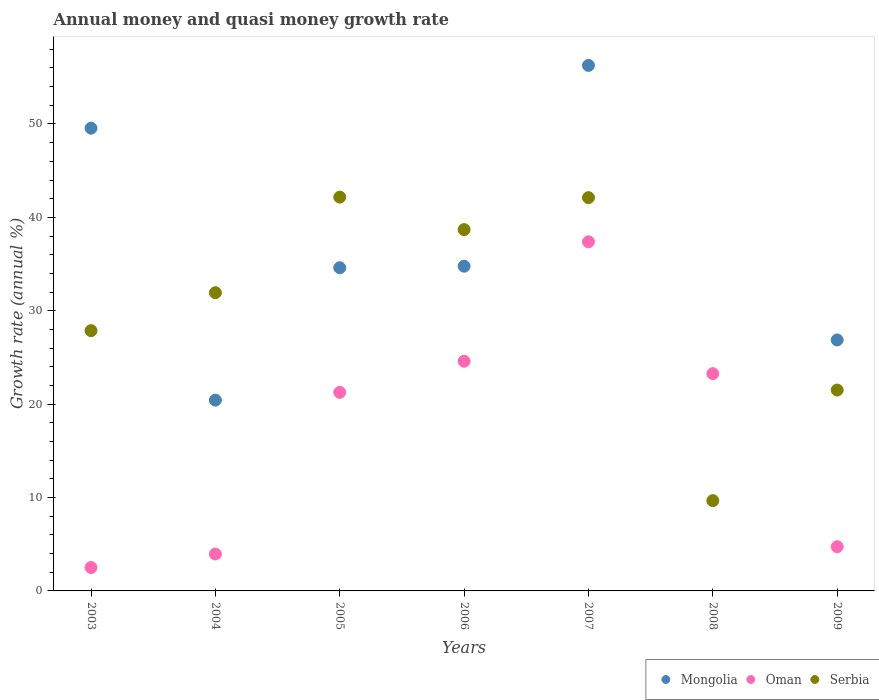What is the growth rate in Oman in 2009?
Provide a short and direct response. 4.73. Across all years, what is the maximum growth rate in Mongolia?
Offer a terse response. 56.27. Across all years, what is the minimum growth rate in Mongolia?
Your response must be concise. 0. What is the total growth rate in Mongolia in the graph?
Your response must be concise. 222.5. What is the difference between the growth rate in Oman in 2003 and that in 2009?
Your answer should be very brief. -2.22. What is the difference between the growth rate in Mongolia in 2004 and the growth rate in Oman in 2005?
Your answer should be very brief. -0.83. What is the average growth rate in Mongolia per year?
Make the answer very short. 31.79. In the year 2007, what is the difference between the growth rate in Mongolia and growth rate in Oman?
Give a very brief answer. 18.89. What is the ratio of the growth rate in Serbia in 2003 to that in 2009?
Provide a succinct answer. 1.3. What is the difference between the highest and the second highest growth rate in Serbia?
Offer a very short reply. 0.06. What is the difference between the highest and the lowest growth rate in Serbia?
Ensure brevity in your answer.  32.5. Does the growth rate in Serbia monotonically increase over the years?
Offer a terse response. No. Is the growth rate in Oman strictly less than the growth rate in Serbia over the years?
Your answer should be very brief. No. How many years are there in the graph?
Your answer should be compact. 7. Are the values on the major ticks of Y-axis written in scientific E-notation?
Your answer should be compact. No. Does the graph contain grids?
Make the answer very short. No. Where does the legend appear in the graph?
Your answer should be compact. Bottom right. How many legend labels are there?
Give a very brief answer. 3. What is the title of the graph?
Ensure brevity in your answer.  Annual money and quasi money growth rate. Does "Algeria" appear as one of the legend labels in the graph?
Your response must be concise. No. What is the label or title of the Y-axis?
Keep it short and to the point. Growth rate (annual %). What is the Growth rate (annual %) of Mongolia in 2003?
Your answer should be very brief. 49.55. What is the Growth rate (annual %) in Oman in 2003?
Keep it short and to the point. 2.51. What is the Growth rate (annual %) of Serbia in 2003?
Offer a very short reply. 27.87. What is the Growth rate (annual %) of Mongolia in 2004?
Make the answer very short. 20.43. What is the Growth rate (annual %) in Oman in 2004?
Offer a very short reply. 3.95. What is the Growth rate (annual %) in Serbia in 2004?
Your response must be concise. 31.93. What is the Growth rate (annual %) of Mongolia in 2005?
Give a very brief answer. 34.61. What is the Growth rate (annual %) in Oman in 2005?
Your answer should be very brief. 21.26. What is the Growth rate (annual %) in Serbia in 2005?
Offer a very short reply. 42.17. What is the Growth rate (annual %) in Mongolia in 2006?
Offer a terse response. 34.77. What is the Growth rate (annual %) in Oman in 2006?
Keep it short and to the point. 24.6. What is the Growth rate (annual %) of Serbia in 2006?
Keep it short and to the point. 38.69. What is the Growth rate (annual %) in Mongolia in 2007?
Your response must be concise. 56.27. What is the Growth rate (annual %) of Oman in 2007?
Offer a very short reply. 37.39. What is the Growth rate (annual %) in Serbia in 2007?
Offer a very short reply. 42.11. What is the Growth rate (annual %) of Oman in 2008?
Offer a very short reply. 23.27. What is the Growth rate (annual %) in Serbia in 2008?
Give a very brief answer. 9.67. What is the Growth rate (annual %) of Mongolia in 2009?
Your answer should be compact. 26.87. What is the Growth rate (annual %) of Oman in 2009?
Provide a short and direct response. 4.73. What is the Growth rate (annual %) in Serbia in 2009?
Keep it short and to the point. 21.51. Across all years, what is the maximum Growth rate (annual %) of Mongolia?
Provide a short and direct response. 56.27. Across all years, what is the maximum Growth rate (annual %) of Oman?
Your answer should be compact. 37.39. Across all years, what is the maximum Growth rate (annual %) of Serbia?
Offer a terse response. 42.17. Across all years, what is the minimum Growth rate (annual %) in Mongolia?
Offer a very short reply. 0. Across all years, what is the minimum Growth rate (annual %) of Oman?
Your answer should be compact. 2.51. Across all years, what is the minimum Growth rate (annual %) in Serbia?
Provide a succinct answer. 9.67. What is the total Growth rate (annual %) in Mongolia in the graph?
Keep it short and to the point. 222.5. What is the total Growth rate (annual %) in Oman in the graph?
Make the answer very short. 117.71. What is the total Growth rate (annual %) of Serbia in the graph?
Give a very brief answer. 213.95. What is the difference between the Growth rate (annual %) in Mongolia in 2003 and that in 2004?
Your answer should be very brief. 29.12. What is the difference between the Growth rate (annual %) of Oman in 2003 and that in 2004?
Make the answer very short. -1.44. What is the difference between the Growth rate (annual %) in Serbia in 2003 and that in 2004?
Provide a succinct answer. -4.06. What is the difference between the Growth rate (annual %) of Mongolia in 2003 and that in 2005?
Offer a very short reply. 14.94. What is the difference between the Growth rate (annual %) of Oman in 2003 and that in 2005?
Offer a terse response. -18.75. What is the difference between the Growth rate (annual %) of Serbia in 2003 and that in 2005?
Keep it short and to the point. -14.3. What is the difference between the Growth rate (annual %) of Mongolia in 2003 and that in 2006?
Provide a short and direct response. 14.78. What is the difference between the Growth rate (annual %) in Oman in 2003 and that in 2006?
Offer a terse response. -22.08. What is the difference between the Growth rate (annual %) of Serbia in 2003 and that in 2006?
Provide a short and direct response. -10.82. What is the difference between the Growth rate (annual %) in Mongolia in 2003 and that in 2007?
Give a very brief answer. -6.72. What is the difference between the Growth rate (annual %) in Oman in 2003 and that in 2007?
Your answer should be very brief. -34.87. What is the difference between the Growth rate (annual %) in Serbia in 2003 and that in 2007?
Offer a very short reply. -14.24. What is the difference between the Growth rate (annual %) in Oman in 2003 and that in 2008?
Ensure brevity in your answer.  -20.76. What is the difference between the Growth rate (annual %) of Serbia in 2003 and that in 2008?
Give a very brief answer. 18.2. What is the difference between the Growth rate (annual %) of Mongolia in 2003 and that in 2009?
Your response must be concise. 22.68. What is the difference between the Growth rate (annual %) in Oman in 2003 and that in 2009?
Offer a terse response. -2.22. What is the difference between the Growth rate (annual %) in Serbia in 2003 and that in 2009?
Keep it short and to the point. 6.36. What is the difference between the Growth rate (annual %) of Mongolia in 2004 and that in 2005?
Offer a terse response. -14.18. What is the difference between the Growth rate (annual %) in Oman in 2004 and that in 2005?
Offer a terse response. -17.31. What is the difference between the Growth rate (annual %) in Serbia in 2004 and that in 2005?
Offer a very short reply. -10.23. What is the difference between the Growth rate (annual %) of Mongolia in 2004 and that in 2006?
Keep it short and to the point. -14.34. What is the difference between the Growth rate (annual %) of Oman in 2004 and that in 2006?
Your answer should be very brief. -20.64. What is the difference between the Growth rate (annual %) of Serbia in 2004 and that in 2006?
Keep it short and to the point. -6.76. What is the difference between the Growth rate (annual %) of Mongolia in 2004 and that in 2007?
Provide a succinct answer. -35.84. What is the difference between the Growth rate (annual %) of Oman in 2004 and that in 2007?
Keep it short and to the point. -33.43. What is the difference between the Growth rate (annual %) in Serbia in 2004 and that in 2007?
Provide a short and direct response. -10.18. What is the difference between the Growth rate (annual %) of Oman in 2004 and that in 2008?
Offer a terse response. -19.31. What is the difference between the Growth rate (annual %) of Serbia in 2004 and that in 2008?
Provide a succinct answer. 22.27. What is the difference between the Growth rate (annual %) in Mongolia in 2004 and that in 2009?
Your response must be concise. -6.44. What is the difference between the Growth rate (annual %) of Oman in 2004 and that in 2009?
Give a very brief answer. -0.78. What is the difference between the Growth rate (annual %) of Serbia in 2004 and that in 2009?
Provide a short and direct response. 10.42. What is the difference between the Growth rate (annual %) of Mongolia in 2005 and that in 2006?
Your answer should be compact. -0.16. What is the difference between the Growth rate (annual %) in Oman in 2005 and that in 2006?
Your answer should be compact. -3.34. What is the difference between the Growth rate (annual %) in Serbia in 2005 and that in 2006?
Offer a very short reply. 3.48. What is the difference between the Growth rate (annual %) of Mongolia in 2005 and that in 2007?
Provide a succinct answer. -21.66. What is the difference between the Growth rate (annual %) in Oman in 2005 and that in 2007?
Your answer should be very brief. -16.13. What is the difference between the Growth rate (annual %) of Serbia in 2005 and that in 2007?
Your answer should be compact. 0.06. What is the difference between the Growth rate (annual %) in Oman in 2005 and that in 2008?
Provide a short and direct response. -2.01. What is the difference between the Growth rate (annual %) in Serbia in 2005 and that in 2008?
Provide a succinct answer. 32.5. What is the difference between the Growth rate (annual %) in Mongolia in 2005 and that in 2009?
Ensure brevity in your answer.  7.73. What is the difference between the Growth rate (annual %) in Oman in 2005 and that in 2009?
Offer a very short reply. 16.53. What is the difference between the Growth rate (annual %) in Serbia in 2005 and that in 2009?
Make the answer very short. 20.66. What is the difference between the Growth rate (annual %) in Mongolia in 2006 and that in 2007?
Keep it short and to the point. -21.5. What is the difference between the Growth rate (annual %) of Oman in 2006 and that in 2007?
Make the answer very short. -12.79. What is the difference between the Growth rate (annual %) in Serbia in 2006 and that in 2007?
Provide a succinct answer. -3.42. What is the difference between the Growth rate (annual %) in Oman in 2006 and that in 2008?
Your response must be concise. 1.33. What is the difference between the Growth rate (annual %) of Serbia in 2006 and that in 2008?
Your response must be concise. 29.02. What is the difference between the Growth rate (annual %) of Mongolia in 2006 and that in 2009?
Offer a terse response. 7.9. What is the difference between the Growth rate (annual %) of Oman in 2006 and that in 2009?
Offer a terse response. 19.86. What is the difference between the Growth rate (annual %) of Serbia in 2006 and that in 2009?
Your answer should be compact. 17.18. What is the difference between the Growth rate (annual %) of Oman in 2007 and that in 2008?
Provide a short and direct response. 14.12. What is the difference between the Growth rate (annual %) in Serbia in 2007 and that in 2008?
Ensure brevity in your answer.  32.44. What is the difference between the Growth rate (annual %) in Mongolia in 2007 and that in 2009?
Ensure brevity in your answer.  29.4. What is the difference between the Growth rate (annual %) of Oman in 2007 and that in 2009?
Ensure brevity in your answer.  32.65. What is the difference between the Growth rate (annual %) in Serbia in 2007 and that in 2009?
Provide a succinct answer. 20.6. What is the difference between the Growth rate (annual %) in Oman in 2008 and that in 2009?
Your answer should be compact. 18.53. What is the difference between the Growth rate (annual %) of Serbia in 2008 and that in 2009?
Your answer should be very brief. -11.84. What is the difference between the Growth rate (annual %) in Mongolia in 2003 and the Growth rate (annual %) in Oman in 2004?
Provide a succinct answer. 45.6. What is the difference between the Growth rate (annual %) in Mongolia in 2003 and the Growth rate (annual %) in Serbia in 2004?
Offer a very short reply. 17.62. What is the difference between the Growth rate (annual %) of Oman in 2003 and the Growth rate (annual %) of Serbia in 2004?
Make the answer very short. -29.42. What is the difference between the Growth rate (annual %) in Mongolia in 2003 and the Growth rate (annual %) in Oman in 2005?
Your answer should be compact. 28.29. What is the difference between the Growth rate (annual %) in Mongolia in 2003 and the Growth rate (annual %) in Serbia in 2005?
Give a very brief answer. 7.38. What is the difference between the Growth rate (annual %) of Oman in 2003 and the Growth rate (annual %) of Serbia in 2005?
Provide a short and direct response. -39.66. What is the difference between the Growth rate (annual %) in Mongolia in 2003 and the Growth rate (annual %) in Oman in 2006?
Your answer should be very brief. 24.95. What is the difference between the Growth rate (annual %) in Mongolia in 2003 and the Growth rate (annual %) in Serbia in 2006?
Make the answer very short. 10.86. What is the difference between the Growth rate (annual %) in Oman in 2003 and the Growth rate (annual %) in Serbia in 2006?
Offer a very short reply. -36.18. What is the difference between the Growth rate (annual %) of Mongolia in 2003 and the Growth rate (annual %) of Oman in 2007?
Your answer should be very brief. 12.16. What is the difference between the Growth rate (annual %) in Mongolia in 2003 and the Growth rate (annual %) in Serbia in 2007?
Ensure brevity in your answer.  7.44. What is the difference between the Growth rate (annual %) in Oman in 2003 and the Growth rate (annual %) in Serbia in 2007?
Provide a short and direct response. -39.6. What is the difference between the Growth rate (annual %) of Mongolia in 2003 and the Growth rate (annual %) of Oman in 2008?
Your answer should be compact. 26.28. What is the difference between the Growth rate (annual %) in Mongolia in 2003 and the Growth rate (annual %) in Serbia in 2008?
Make the answer very short. 39.88. What is the difference between the Growth rate (annual %) of Oman in 2003 and the Growth rate (annual %) of Serbia in 2008?
Keep it short and to the point. -7.16. What is the difference between the Growth rate (annual %) in Mongolia in 2003 and the Growth rate (annual %) in Oman in 2009?
Provide a short and direct response. 44.82. What is the difference between the Growth rate (annual %) in Mongolia in 2003 and the Growth rate (annual %) in Serbia in 2009?
Provide a short and direct response. 28.04. What is the difference between the Growth rate (annual %) of Oman in 2003 and the Growth rate (annual %) of Serbia in 2009?
Ensure brevity in your answer.  -19. What is the difference between the Growth rate (annual %) of Mongolia in 2004 and the Growth rate (annual %) of Oman in 2005?
Make the answer very short. -0.83. What is the difference between the Growth rate (annual %) in Mongolia in 2004 and the Growth rate (annual %) in Serbia in 2005?
Your answer should be very brief. -21.74. What is the difference between the Growth rate (annual %) in Oman in 2004 and the Growth rate (annual %) in Serbia in 2005?
Offer a terse response. -38.22. What is the difference between the Growth rate (annual %) of Mongolia in 2004 and the Growth rate (annual %) of Oman in 2006?
Ensure brevity in your answer.  -4.16. What is the difference between the Growth rate (annual %) of Mongolia in 2004 and the Growth rate (annual %) of Serbia in 2006?
Make the answer very short. -18.26. What is the difference between the Growth rate (annual %) of Oman in 2004 and the Growth rate (annual %) of Serbia in 2006?
Make the answer very short. -34.74. What is the difference between the Growth rate (annual %) of Mongolia in 2004 and the Growth rate (annual %) of Oman in 2007?
Your response must be concise. -16.95. What is the difference between the Growth rate (annual %) in Mongolia in 2004 and the Growth rate (annual %) in Serbia in 2007?
Offer a very short reply. -21.68. What is the difference between the Growth rate (annual %) in Oman in 2004 and the Growth rate (annual %) in Serbia in 2007?
Ensure brevity in your answer.  -38.16. What is the difference between the Growth rate (annual %) in Mongolia in 2004 and the Growth rate (annual %) in Oman in 2008?
Ensure brevity in your answer.  -2.83. What is the difference between the Growth rate (annual %) in Mongolia in 2004 and the Growth rate (annual %) in Serbia in 2008?
Give a very brief answer. 10.76. What is the difference between the Growth rate (annual %) in Oman in 2004 and the Growth rate (annual %) in Serbia in 2008?
Ensure brevity in your answer.  -5.72. What is the difference between the Growth rate (annual %) in Mongolia in 2004 and the Growth rate (annual %) in Oman in 2009?
Your response must be concise. 15.7. What is the difference between the Growth rate (annual %) of Mongolia in 2004 and the Growth rate (annual %) of Serbia in 2009?
Offer a terse response. -1.08. What is the difference between the Growth rate (annual %) of Oman in 2004 and the Growth rate (annual %) of Serbia in 2009?
Provide a succinct answer. -17.56. What is the difference between the Growth rate (annual %) of Mongolia in 2005 and the Growth rate (annual %) of Oman in 2006?
Ensure brevity in your answer.  10.01. What is the difference between the Growth rate (annual %) of Mongolia in 2005 and the Growth rate (annual %) of Serbia in 2006?
Your response must be concise. -4.08. What is the difference between the Growth rate (annual %) of Oman in 2005 and the Growth rate (annual %) of Serbia in 2006?
Give a very brief answer. -17.43. What is the difference between the Growth rate (annual %) in Mongolia in 2005 and the Growth rate (annual %) in Oman in 2007?
Your response must be concise. -2.78. What is the difference between the Growth rate (annual %) of Mongolia in 2005 and the Growth rate (annual %) of Serbia in 2007?
Your answer should be very brief. -7.5. What is the difference between the Growth rate (annual %) in Oman in 2005 and the Growth rate (annual %) in Serbia in 2007?
Offer a terse response. -20.85. What is the difference between the Growth rate (annual %) in Mongolia in 2005 and the Growth rate (annual %) in Oman in 2008?
Offer a very short reply. 11.34. What is the difference between the Growth rate (annual %) of Mongolia in 2005 and the Growth rate (annual %) of Serbia in 2008?
Your answer should be very brief. 24.94. What is the difference between the Growth rate (annual %) in Oman in 2005 and the Growth rate (annual %) in Serbia in 2008?
Your answer should be compact. 11.59. What is the difference between the Growth rate (annual %) in Mongolia in 2005 and the Growth rate (annual %) in Oman in 2009?
Offer a terse response. 29.87. What is the difference between the Growth rate (annual %) in Mongolia in 2005 and the Growth rate (annual %) in Serbia in 2009?
Keep it short and to the point. 13.1. What is the difference between the Growth rate (annual %) of Oman in 2005 and the Growth rate (annual %) of Serbia in 2009?
Your answer should be very brief. -0.25. What is the difference between the Growth rate (annual %) of Mongolia in 2006 and the Growth rate (annual %) of Oman in 2007?
Your response must be concise. -2.62. What is the difference between the Growth rate (annual %) in Mongolia in 2006 and the Growth rate (annual %) in Serbia in 2007?
Ensure brevity in your answer.  -7.34. What is the difference between the Growth rate (annual %) in Oman in 2006 and the Growth rate (annual %) in Serbia in 2007?
Offer a terse response. -17.51. What is the difference between the Growth rate (annual %) in Mongolia in 2006 and the Growth rate (annual %) in Oman in 2008?
Give a very brief answer. 11.5. What is the difference between the Growth rate (annual %) in Mongolia in 2006 and the Growth rate (annual %) in Serbia in 2008?
Your answer should be very brief. 25.1. What is the difference between the Growth rate (annual %) in Oman in 2006 and the Growth rate (annual %) in Serbia in 2008?
Your response must be concise. 14.93. What is the difference between the Growth rate (annual %) of Mongolia in 2006 and the Growth rate (annual %) of Oman in 2009?
Provide a short and direct response. 30.03. What is the difference between the Growth rate (annual %) of Mongolia in 2006 and the Growth rate (annual %) of Serbia in 2009?
Keep it short and to the point. 13.26. What is the difference between the Growth rate (annual %) of Oman in 2006 and the Growth rate (annual %) of Serbia in 2009?
Offer a very short reply. 3.08. What is the difference between the Growth rate (annual %) in Mongolia in 2007 and the Growth rate (annual %) in Oman in 2008?
Your response must be concise. 33.01. What is the difference between the Growth rate (annual %) in Mongolia in 2007 and the Growth rate (annual %) in Serbia in 2008?
Provide a short and direct response. 46.6. What is the difference between the Growth rate (annual %) in Oman in 2007 and the Growth rate (annual %) in Serbia in 2008?
Provide a succinct answer. 27.72. What is the difference between the Growth rate (annual %) of Mongolia in 2007 and the Growth rate (annual %) of Oman in 2009?
Make the answer very short. 51.54. What is the difference between the Growth rate (annual %) of Mongolia in 2007 and the Growth rate (annual %) of Serbia in 2009?
Your answer should be compact. 34.76. What is the difference between the Growth rate (annual %) of Oman in 2007 and the Growth rate (annual %) of Serbia in 2009?
Give a very brief answer. 15.87. What is the difference between the Growth rate (annual %) in Oman in 2008 and the Growth rate (annual %) in Serbia in 2009?
Your answer should be compact. 1.76. What is the average Growth rate (annual %) in Mongolia per year?
Provide a short and direct response. 31.79. What is the average Growth rate (annual %) in Oman per year?
Provide a succinct answer. 16.82. What is the average Growth rate (annual %) of Serbia per year?
Your answer should be very brief. 30.56. In the year 2003, what is the difference between the Growth rate (annual %) of Mongolia and Growth rate (annual %) of Oman?
Your response must be concise. 47.04. In the year 2003, what is the difference between the Growth rate (annual %) in Mongolia and Growth rate (annual %) in Serbia?
Ensure brevity in your answer.  21.68. In the year 2003, what is the difference between the Growth rate (annual %) of Oman and Growth rate (annual %) of Serbia?
Offer a terse response. -25.36. In the year 2004, what is the difference between the Growth rate (annual %) in Mongolia and Growth rate (annual %) in Oman?
Give a very brief answer. 16.48. In the year 2004, what is the difference between the Growth rate (annual %) in Mongolia and Growth rate (annual %) in Serbia?
Provide a succinct answer. -11.5. In the year 2004, what is the difference between the Growth rate (annual %) in Oman and Growth rate (annual %) in Serbia?
Your response must be concise. -27.98. In the year 2005, what is the difference between the Growth rate (annual %) of Mongolia and Growth rate (annual %) of Oman?
Offer a very short reply. 13.35. In the year 2005, what is the difference between the Growth rate (annual %) of Mongolia and Growth rate (annual %) of Serbia?
Provide a short and direct response. -7.56. In the year 2005, what is the difference between the Growth rate (annual %) in Oman and Growth rate (annual %) in Serbia?
Keep it short and to the point. -20.91. In the year 2006, what is the difference between the Growth rate (annual %) of Mongolia and Growth rate (annual %) of Oman?
Give a very brief answer. 10.17. In the year 2006, what is the difference between the Growth rate (annual %) of Mongolia and Growth rate (annual %) of Serbia?
Make the answer very short. -3.92. In the year 2006, what is the difference between the Growth rate (annual %) of Oman and Growth rate (annual %) of Serbia?
Keep it short and to the point. -14.09. In the year 2007, what is the difference between the Growth rate (annual %) in Mongolia and Growth rate (annual %) in Oman?
Keep it short and to the point. 18.89. In the year 2007, what is the difference between the Growth rate (annual %) of Mongolia and Growth rate (annual %) of Serbia?
Keep it short and to the point. 14.16. In the year 2007, what is the difference between the Growth rate (annual %) of Oman and Growth rate (annual %) of Serbia?
Provide a succinct answer. -4.72. In the year 2008, what is the difference between the Growth rate (annual %) in Oman and Growth rate (annual %) in Serbia?
Your answer should be compact. 13.6. In the year 2009, what is the difference between the Growth rate (annual %) in Mongolia and Growth rate (annual %) in Oman?
Offer a very short reply. 22.14. In the year 2009, what is the difference between the Growth rate (annual %) of Mongolia and Growth rate (annual %) of Serbia?
Ensure brevity in your answer.  5.36. In the year 2009, what is the difference between the Growth rate (annual %) in Oman and Growth rate (annual %) in Serbia?
Offer a very short reply. -16.78. What is the ratio of the Growth rate (annual %) in Mongolia in 2003 to that in 2004?
Your answer should be compact. 2.43. What is the ratio of the Growth rate (annual %) in Oman in 2003 to that in 2004?
Keep it short and to the point. 0.64. What is the ratio of the Growth rate (annual %) of Serbia in 2003 to that in 2004?
Your response must be concise. 0.87. What is the ratio of the Growth rate (annual %) of Mongolia in 2003 to that in 2005?
Your answer should be compact. 1.43. What is the ratio of the Growth rate (annual %) in Oman in 2003 to that in 2005?
Your answer should be very brief. 0.12. What is the ratio of the Growth rate (annual %) of Serbia in 2003 to that in 2005?
Your answer should be compact. 0.66. What is the ratio of the Growth rate (annual %) in Mongolia in 2003 to that in 2006?
Keep it short and to the point. 1.43. What is the ratio of the Growth rate (annual %) in Oman in 2003 to that in 2006?
Your answer should be very brief. 0.1. What is the ratio of the Growth rate (annual %) in Serbia in 2003 to that in 2006?
Offer a very short reply. 0.72. What is the ratio of the Growth rate (annual %) of Mongolia in 2003 to that in 2007?
Provide a succinct answer. 0.88. What is the ratio of the Growth rate (annual %) of Oman in 2003 to that in 2007?
Offer a very short reply. 0.07. What is the ratio of the Growth rate (annual %) in Serbia in 2003 to that in 2007?
Provide a succinct answer. 0.66. What is the ratio of the Growth rate (annual %) in Oman in 2003 to that in 2008?
Provide a succinct answer. 0.11. What is the ratio of the Growth rate (annual %) of Serbia in 2003 to that in 2008?
Give a very brief answer. 2.88. What is the ratio of the Growth rate (annual %) in Mongolia in 2003 to that in 2009?
Offer a terse response. 1.84. What is the ratio of the Growth rate (annual %) of Oman in 2003 to that in 2009?
Give a very brief answer. 0.53. What is the ratio of the Growth rate (annual %) of Serbia in 2003 to that in 2009?
Offer a terse response. 1.3. What is the ratio of the Growth rate (annual %) in Mongolia in 2004 to that in 2005?
Your response must be concise. 0.59. What is the ratio of the Growth rate (annual %) of Oman in 2004 to that in 2005?
Your answer should be very brief. 0.19. What is the ratio of the Growth rate (annual %) in Serbia in 2004 to that in 2005?
Offer a very short reply. 0.76. What is the ratio of the Growth rate (annual %) in Mongolia in 2004 to that in 2006?
Your response must be concise. 0.59. What is the ratio of the Growth rate (annual %) in Oman in 2004 to that in 2006?
Keep it short and to the point. 0.16. What is the ratio of the Growth rate (annual %) in Serbia in 2004 to that in 2006?
Your answer should be very brief. 0.83. What is the ratio of the Growth rate (annual %) of Mongolia in 2004 to that in 2007?
Offer a very short reply. 0.36. What is the ratio of the Growth rate (annual %) in Oman in 2004 to that in 2007?
Your response must be concise. 0.11. What is the ratio of the Growth rate (annual %) in Serbia in 2004 to that in 2007?
Offer a terse response. 0.76. What is the ratio of the Growth rate (annual %) of Oman in 2004 to that in 2008?
Your answer should be compact. 0.17. What is the ratio of the Growth rate (annual %) of Serbia in 2004 to that in 2008?
Provide a succinct answer. 3.3. What is the ratio of the Growth rate (annual %) in Mongolia in 2004 to that in 2009?
Your answer should be compact. 0.76. What is the ratio of the Growth rate (annual %) of Oman in 2004 to that in 2009?
Make the answer very short. 0.83. What is the ratio of the Growth rate (annual %) of Serbia in 2004 to that in 2009?
Keep it short and to the point. 1.48. What is the ratio of the Growth rate (annual %) in Mongolia in 2005 to that in 2006?
Offer a very short reply. 1. What is the ratio of the Growth rate (annual %) in Oman in 2005 to that in 2006?
Provide a succinct answer. 0.86. What is the ratio of the Growth rate (annual %) of Serbia in 2005 to that in 2006?
Provide a succinct answer. 1.09. What is the ratio of the Growth rate (annual %) in Mongolia in 2005 to that in 2007?
Your response must be concise. 0.61. What is the ratio of the Growth rate (annual %) of Oman in 2005 to that in 2007?
Ensure brevity in your answer.  0.57. What is the ratio of the Growth rate (annual %) of Serbia in 2005 to that in 2007?
Keep it short and to the point. 1. What is the ratio of the Growth rate (annual %) of Oman in 2005 to that in 2008?
Your answer should be compact. 0.91. What is the ratio of the Growth rate (annual %) of Serbia in 2005 to that in 2008?
Ensure brevity in your answer.  4.36. What is the ratio of the Growth rate (annual %) of Mongolia in 2005 to that in 2009?
Provide a succinct answer. 1.29. What is the ratio of the Growth rate (annual %) in Oman in 2005 to that in 2009?
Ensure brevity in your answer.  4.49. What is the ratio of the Growth rate (annual %) of Serbia in 2005 to that in 2009?
Provide a succinct answer. 1.96. What is the ratio of the Growth rate (annual %) in Mongolia in 2006 to that in 2007?
Provide a short and direct response. 0.62. What is the ratio of the Growth rate (annual %) of Oman in 2006 to that in 2007?
Give a very brief answer. 0.66. What is the ratio of the Growth rate (annual %) of Serbia in 2006 to that in 2007?
Offer a very short reply. 0.92. What is the ratio of the Growth rate (annual %) in Oman in 2006 to that in 2008?
Make the answer very short. 1.06. What is the ratio of the Growth rate (annual %) of Serbia in 2006 to that in 2008?
Provide a succinct answer. 4. What is the ratio of the Growth rate (annual %) in Mongolia in 2006 to that in 2009?
Offer a terse response. 1.29. What is the ratio of the Growth rate (annual %) of Oman in 2006 to that in 2009?
Offer a very short reply. 5.19. What is the ratio of the Growth rate (annual %) of Serbia in 2006 to that in 2009?
Ensure brevity in your answer.  1.8. What is the ratio of the Growth rate (annual %) in Oman in 2007 to that in 2008?
Your answer should be very brief. 1.61. What is the ratio of the Growth rate (annual %) of Serbia in 2007 to that in 2008?
Offer a very short reply. 4.36. What is the ratio of the Growth rate (annual %) in Mongolia in 2007 to that in 2009?
Offer a terse response. 2.09. What is the ratio of the Growth rate (annual %) of Oman in 2007 to that in 2009?
Offer a terse response. 7.9. What is the ratio of the Growth rate (annual %) of Serbia in 2007 to that in 2009?
Your answer should be compact. 1.96. What is the ratio of the Growth rate (annual %) of Oman in 2008 to that in 2009?
Make the answer very short. 4.91. What is the ratio of the Growth rate (annual %) of Serbia in 2008 to that in 2009?
Make the answer very short. 0.45. What is the difference between the highest and the second highest Growth rate (annual %) in Mongolia?
Provide a succinct answer. 6.72. What is the difference between the highest and the second highest Growth rate (annual %) in Oman?
Offer a very short reply. 12.79. What is the difference between the highest and the second highest Growth rate (annual %) in Serbia?
Make the answer very short. 0.06. What is the difference between the highest and the lowest Growth rate (annual %) in Mongolia?
Provide a succinct answer. 56.27. What is the difference between the highest and the lowest Growth rate (annual %) in Oman?
Ensure brevity in your answer.  34.87. What is the difference between the highest and the lowest Growth rate (annual %) of Serbia?
Provide a short and direct response. 32.5. 